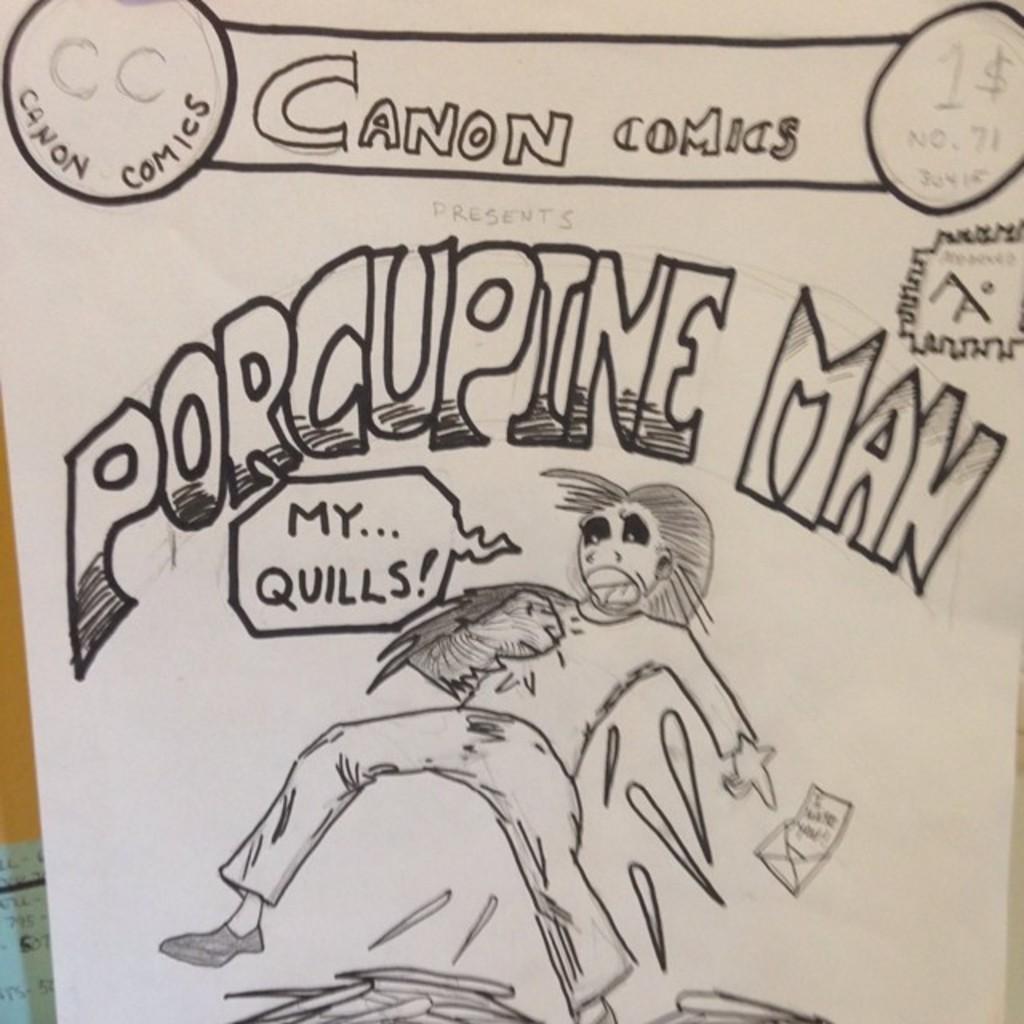Describe this image in one or two sentences. In the foreground of this image, there is a sketch of a person and some text at the top on a paper. 